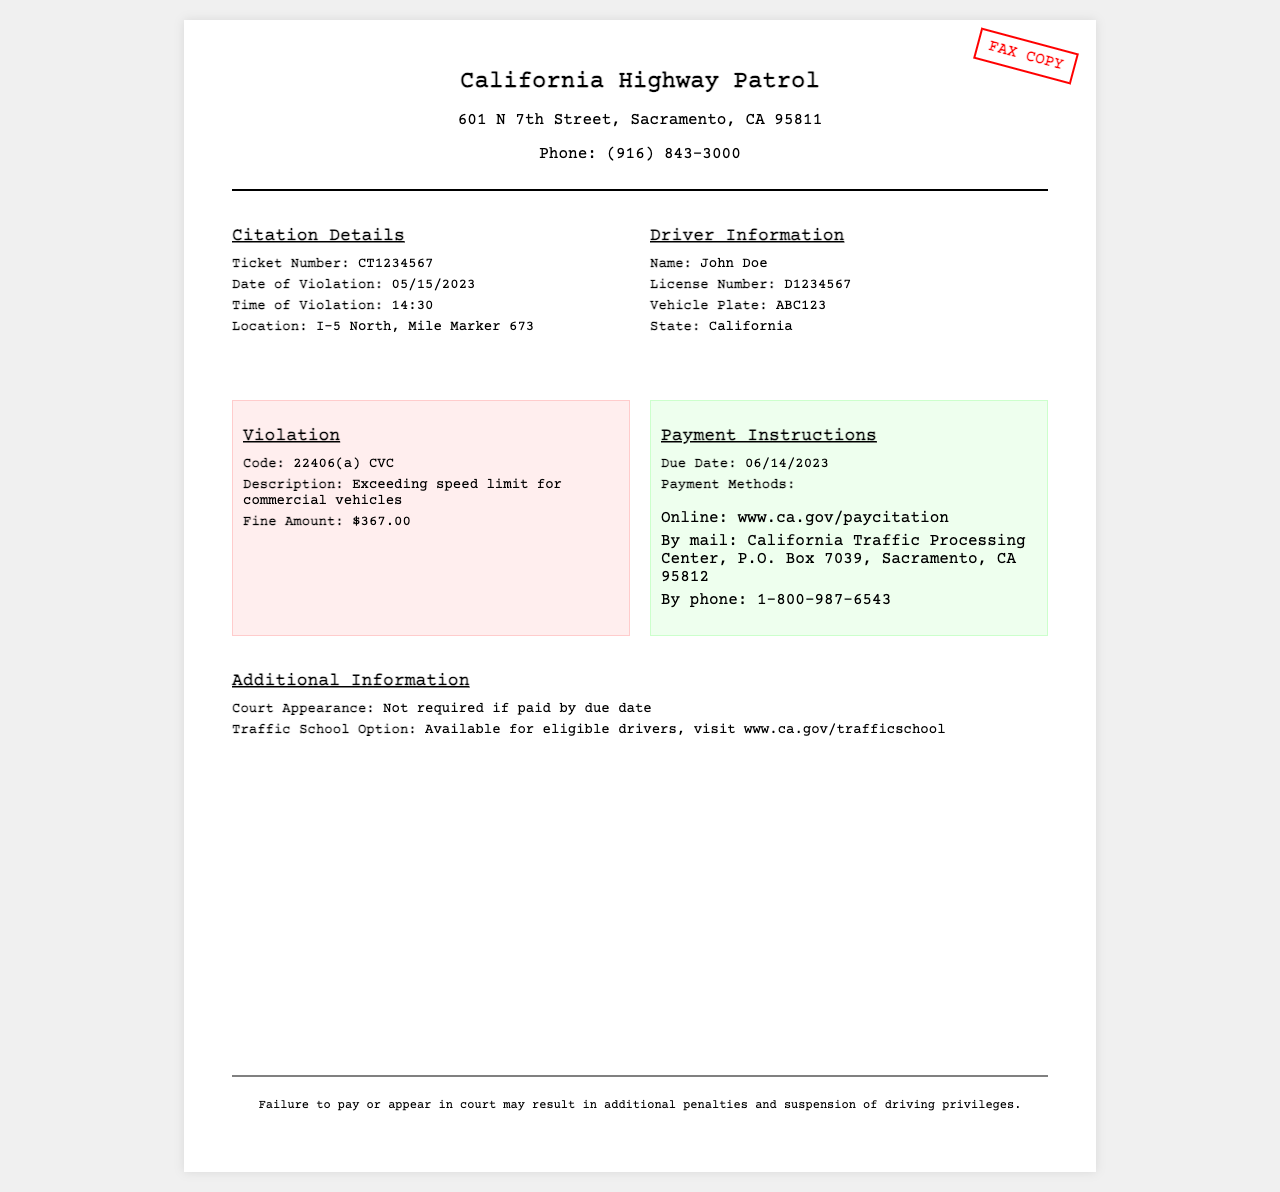What is the ticket number? The ticket number is specifically mentioned in the citation details section of the document.
Answer: CT1234567 Who is the driver? The name of the driver is listed under the driver information section of the document.
Answer: John Doe What was the fine amount? The fine amount is indicated in the violation details section of the document.
Answer: $367.00 When is the due date for the payment? The due date is specified in the payment instructions section of the document.
Answer: 06/14/2023 What speed violation code is mentioned? The code is provided in the violation details section, indicating a specific infraction.
Answer: 22406(a) CVC Is court appearance required? This information is provided in the additional information section and clarifies the need for a court appearance based on payment.
Answer: Not required What payment method is listed for online payment? The document specifies the online payment method in the payment instructions section, detailing how to pay.
Answer: www.ca.gov/paycitation What location is mentioned for the violation? The location of the violation is detailed in the citation section, providing a specific area.
Answer: I-5 North, Mile Marker 673 